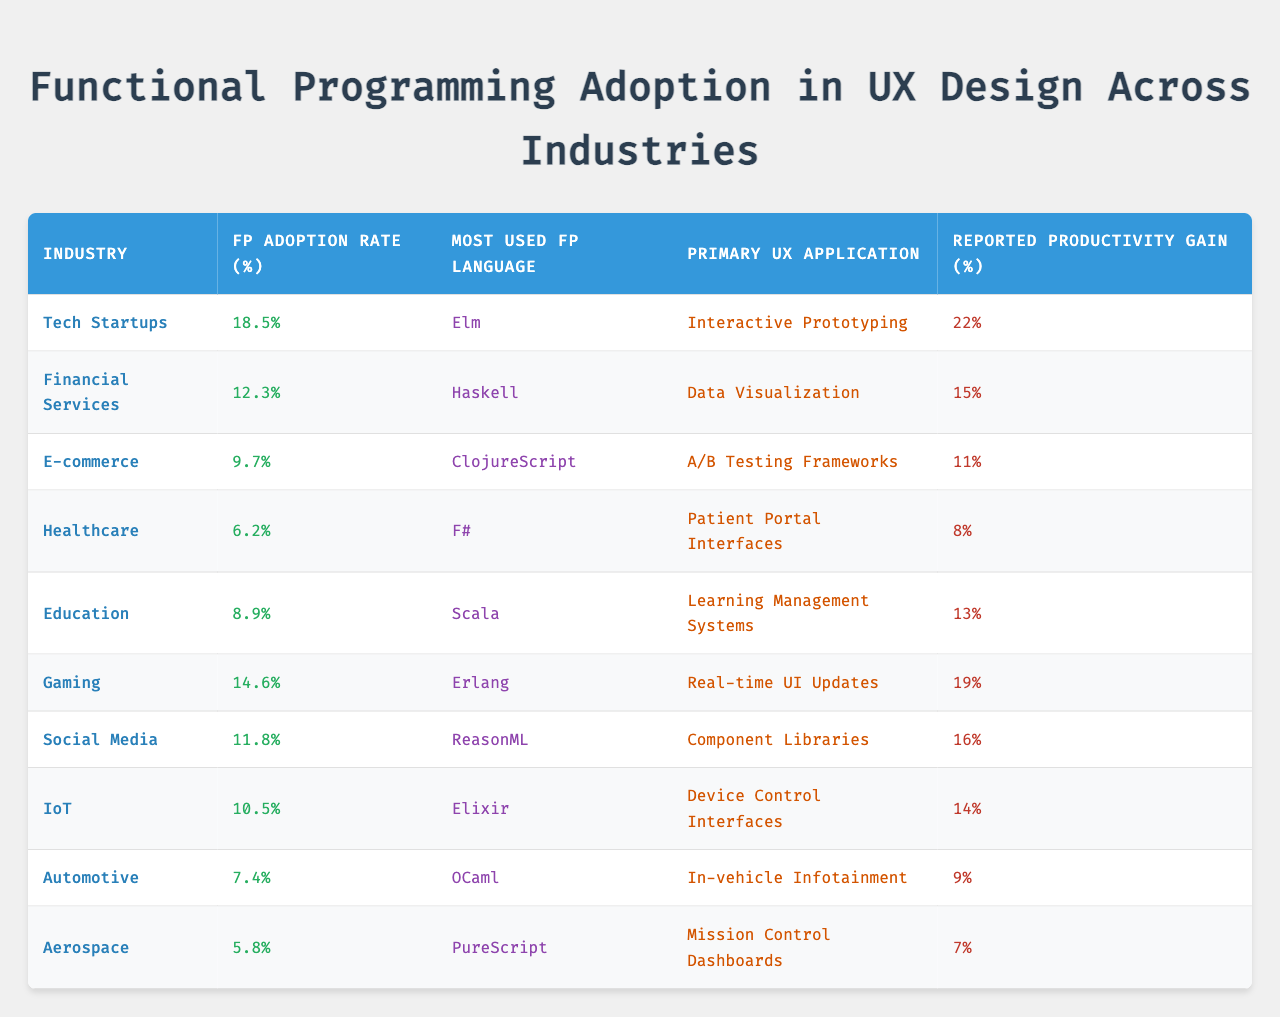What is the FP adoption rate in Tech Startups? The table states that the FP adoption rate for Tech Startups is 18.5%.
Answer: 18.5% Which industry has the highest reported productivity gain? Looking at the reported productivity gains in the table, Tech Startups show the highest at 22%.
Answer: Tech Startups Is Haskell the most used FP language in Financial Services? The table shows that Haskell is indeed the most used FP language in Financial Services.
Answer: Yes What is the average FP adoption rate across all industries listed? To find the average, sum the adoption rates: 18.5 + 12.3 + 9.7 + 6.2 + 8.9 + 14.6 + 11.8 + 10.5 + 7.4 + 5.8 = 89.3%. There are 10 industries, so average = 89.3 / 10 = 8.93%.
Answer: 8.93% Which industry uses Elixir the most for UX applications? The table indicates that IoT is the industry where Elixir is the most used FP language.
Answer: IoT How does the productivity gain in Healthcare compare to that in E-commerce? Healthcare has a productivity gain of 8%, while E-commerce has 11%. The difference is 11% - 8% = 3%.
Answer: E-commerce has a higher productivity gain by 3% If the FP adoption rate of Gaming increased by 3%, what would be its new rate? Gaming currently has an adoption rate of 14.6%. Adding 3% gives 14.6 + 3 = 17.6%.
Answer: 17.6% Are there any industries where the FP adoption rate is below 10%? The table shows that Healthcare, E-commerce, Automotive, and Aerospace all have adoption rates below 10%.
Answer: Yes What is the total reported productivity gain from the Healthcare and Aerospace industries? The reported gains are 8% (Healthcare) and 7% (Aerospace). Summing these gives 8 + 7 = 15%.
Answer: 15% Which FP language is most commonly used in the Automotive industry? According to the table, OCaml is the most commonly used FP language in the Automotive industry.
Answer: OCaml 